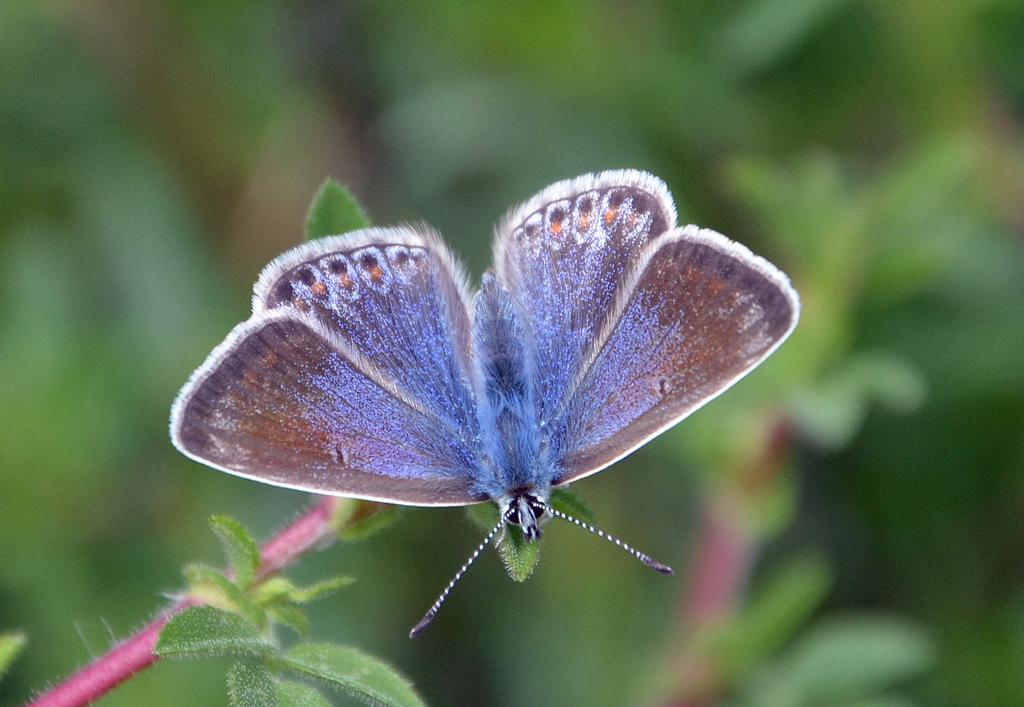What is the main subject in the foreground of the image? There is a butterfly in the foreground of the image. Where is the butterfly located? The butterfly is on a leaf. Can you describe the background of the image? The background of the image is blurry. How does the butterfly help the dad balance the whistle in the image? There is no dad or whistle present in the image, and therefore no such interaction can be observed. 